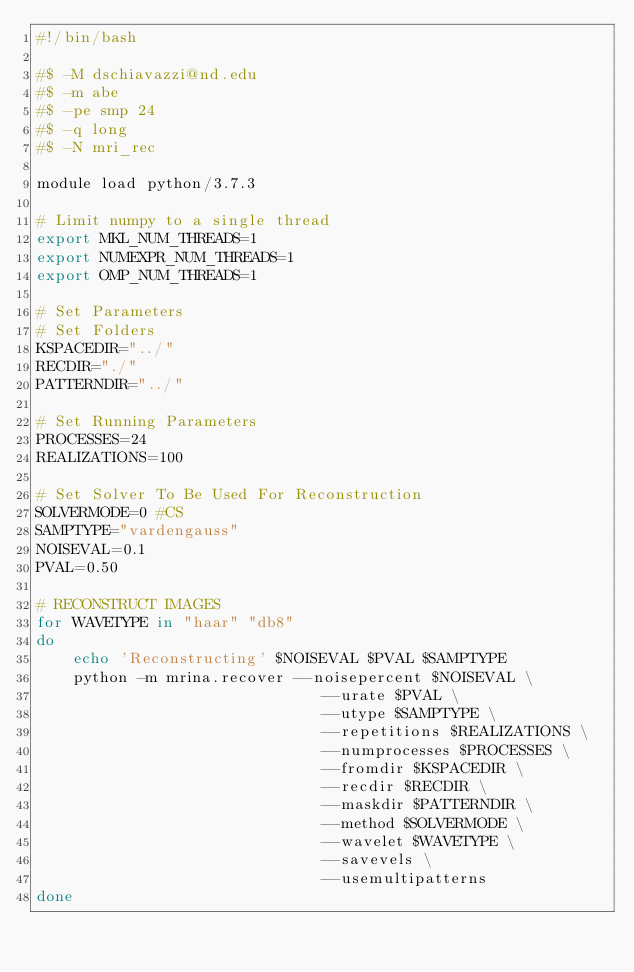Convert code to text. <code><loc_0><loc_0><loc_500><loc_500><_Bash_>#!/bin/bash

#$ -M dschiavazzi@nd.edu
#$ -m abe
#$ -pe smp 24
#$ -q long
#$ -N mri_rec

module load python/3.7.3

# Limit numpy to a single thread
export MKL_NUM_THREADS=1
export NUMEXPR_NUM_THREADS=1
export OMP_NUM_THREADS=1

# Set Parameters 
# Set Folders
KSPACEDIR="../"
RECDIR="./"
PATTERNDIR="../"

# Set Running Parameters
PROCESSES=24
REALIZATIONS=100

# Set Solver To Be Used For Reconstruction
SOLVERMODE=0 #CS
SAMPTYPE="vardengauss"
NOISEVAL=0.1
PVAL=0.50

# RECONSTRUCT IMAGES
for WAVETYPE in "haar" "db8"
do
    echo 'Reconstructing' $NOISEVAL $PVAL $SAMPTYPE
    python -m mrina.recover --noisepercent $NOISEVAL \
                               --urate $PVAL \
                               --utype $SAMPTYPE \
                               --repetitions $REALIZATIONS \
                               --numprocesses $PROCESSES \
                               --fromdir $KSPACEDIR \
                               --recdir $RECDIR \
                               --maskdir $PATTERNDIR \
                               --method $SOLVERMODE \
                               --wavelet $WAVETYPE \
                               --savevels \
                               --usemultipatterns
done
</code> 